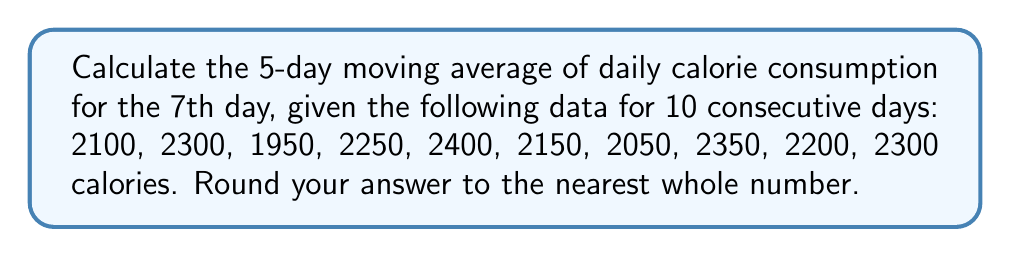Can you solve this math problem? To calculate the 5-day moving average for the 7th day, we need to:

1. Identify the relevant 5-day window: days 3 to 7
2. Sum the calorie consumption for these 5 days
3. Divide the sum by 5
4. Round to the nearest whole number

Step 1: Identify the relevant 5-day window
Days 3 to 7: 1950, 2250, 2400, 2150, 2050

Step 2: Sum the calorie consumption
$$S = 1950 + 2250 + 2400 + 2150 + 2050 = 10800$$

Step 3: Calculate the average
$$A = \frac{S}{5} = \frac{10800}{5} = 2160$$

Step 4: Round to the nearest whole number
2160 is already a whole number, so no rounding is necessary.

Therefore, the 5-day moving average of daily calorie consumption for the 7th day is 2160 calories.
Answer: 2160 